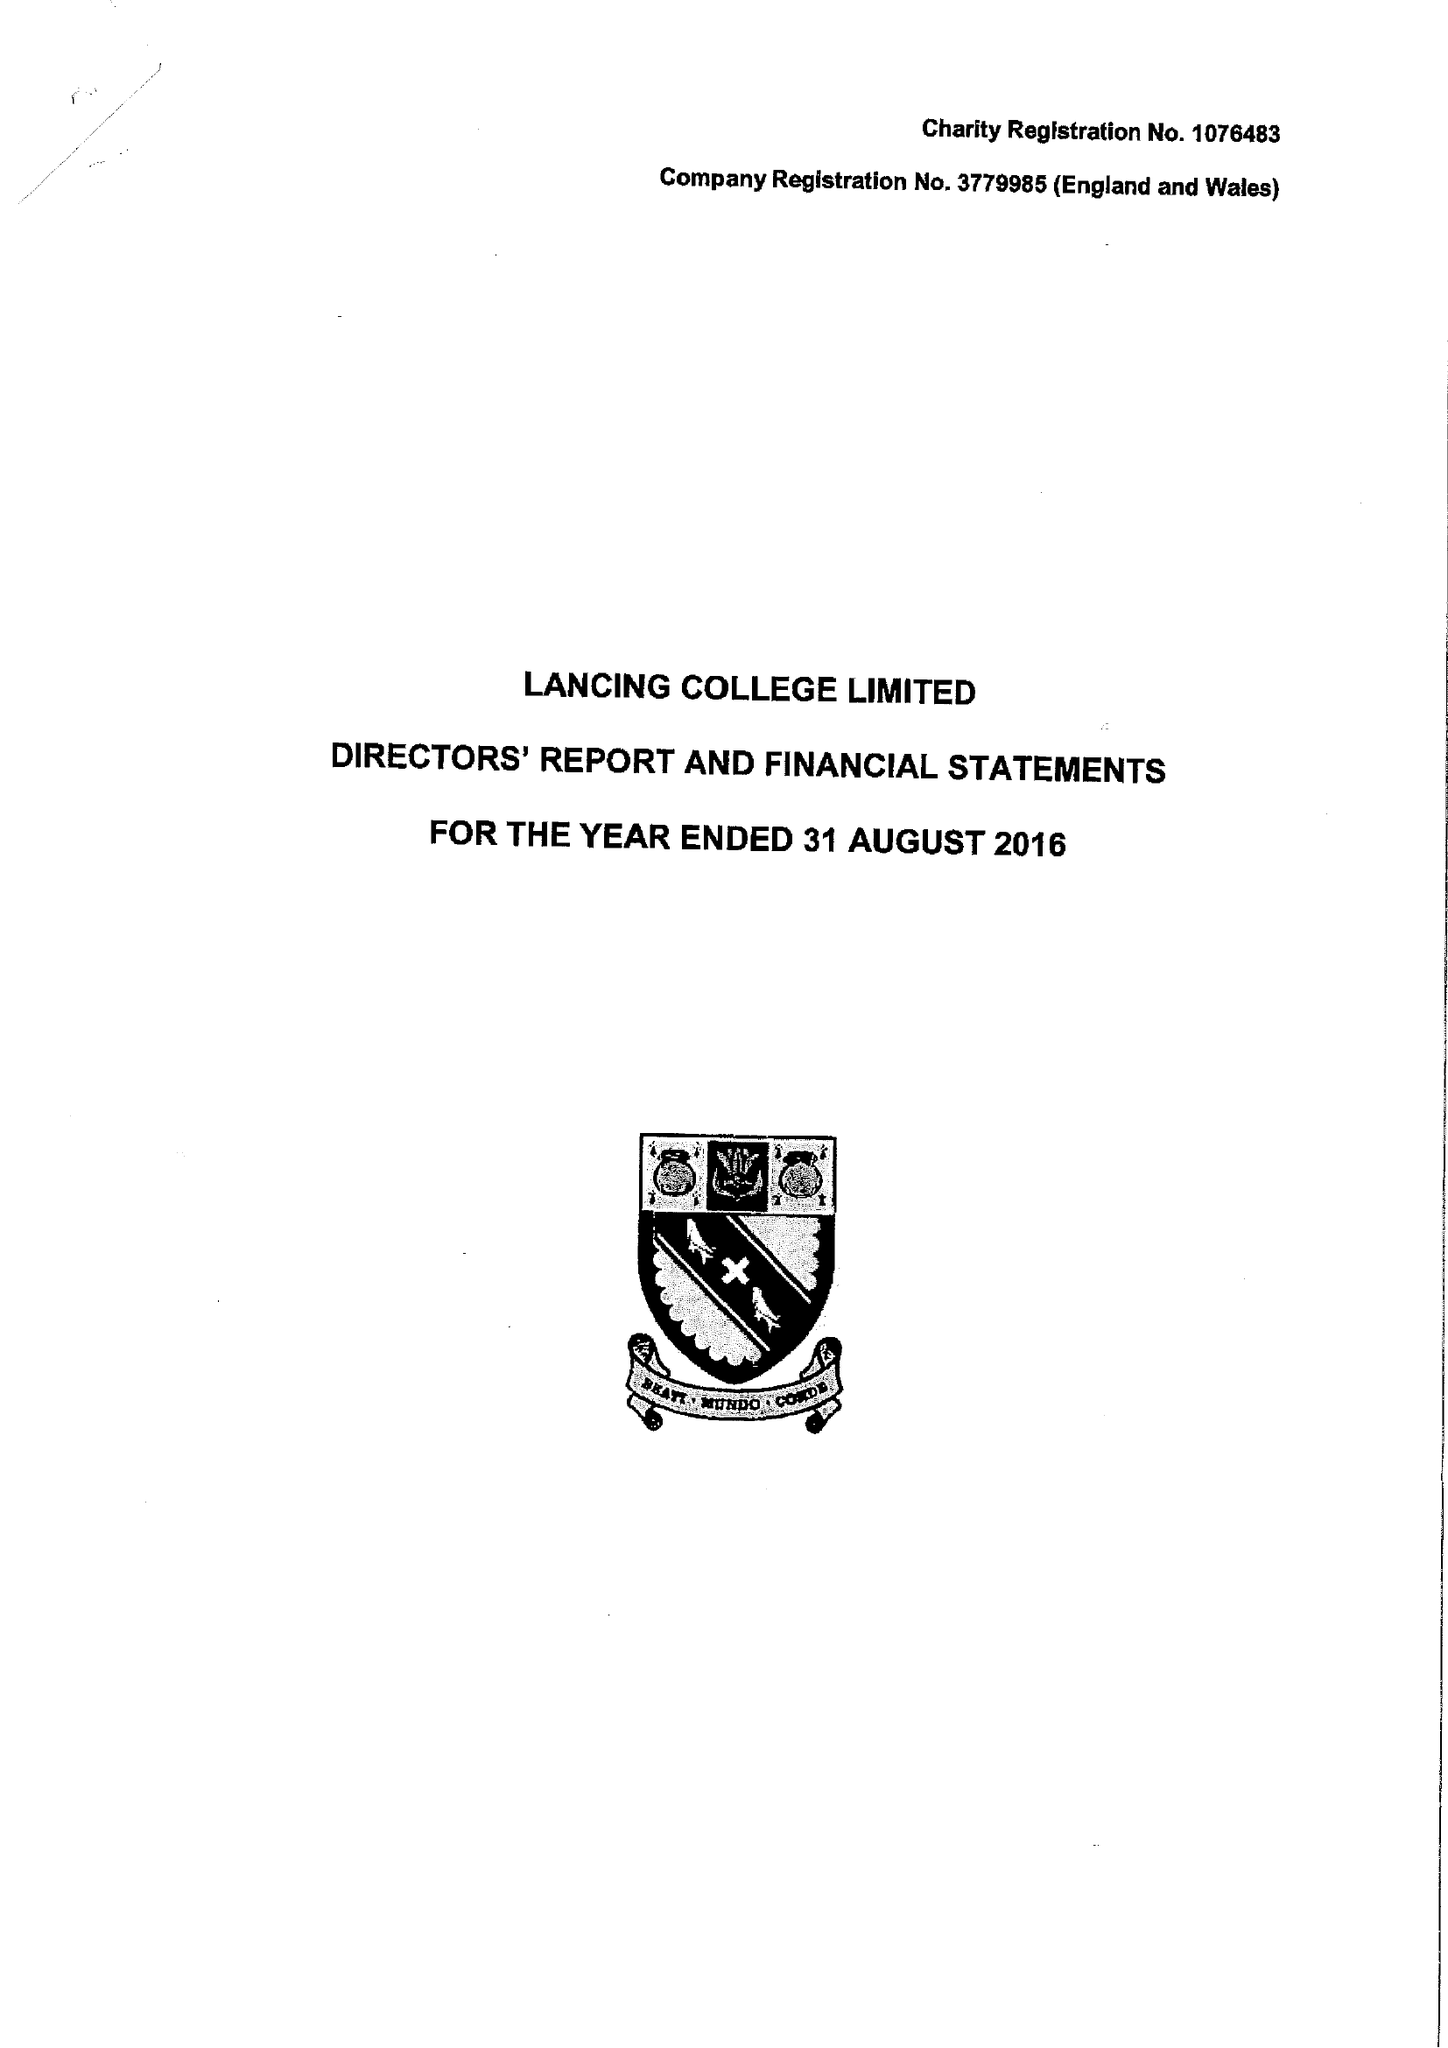What is the value for the address__street_line?
Answer the question using a single word or phrase. None 